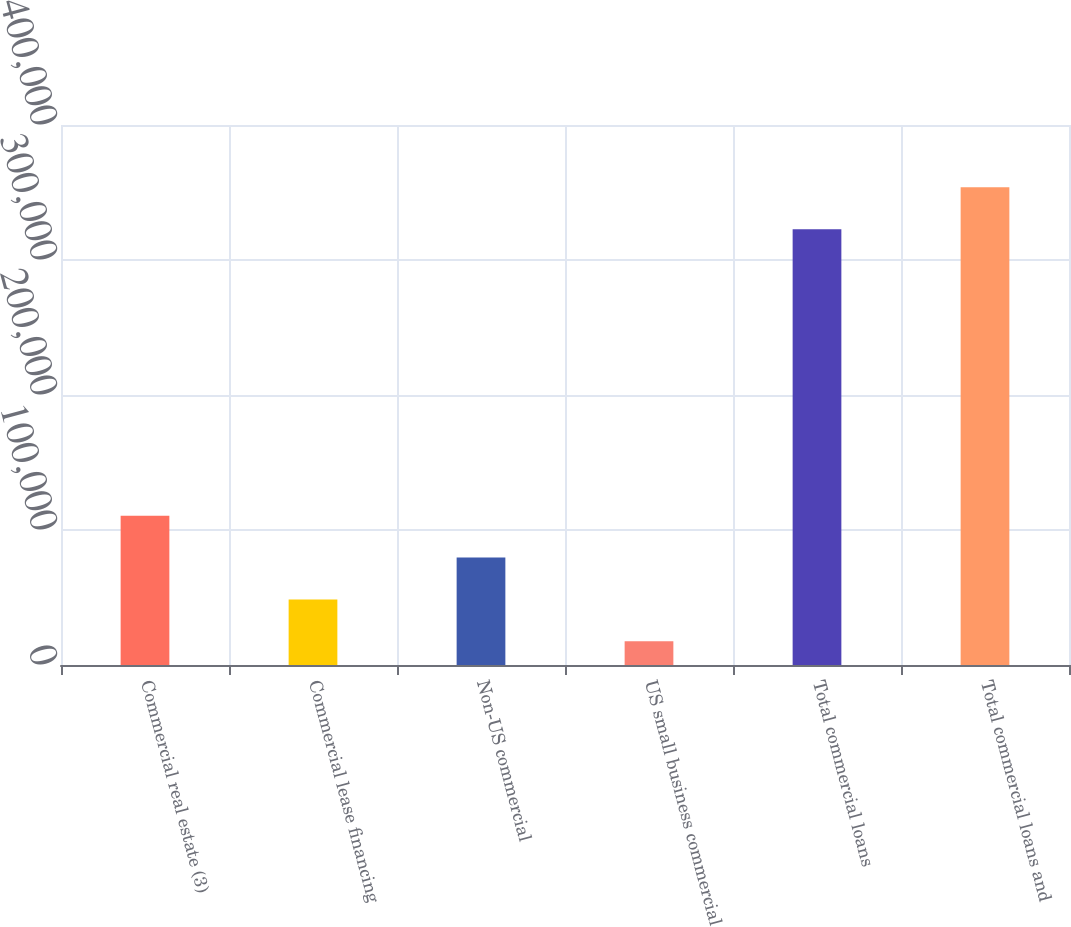Convert chart. <chart><loc_0><loc_0><loc_500><loc_500><bar_chart><fcel>Commercial real estate (3)<fcel>Commercial lease financing<fcel>Non-US commercial<fcel>US small business commercial<fcel>Total commercial loans<fcel>Total commercial loans and<nl><fcel>110606<fcel>48552.6<fcel>79579.2<fcel>17526<fcel>322856<fcel>353883<nl></chart> 